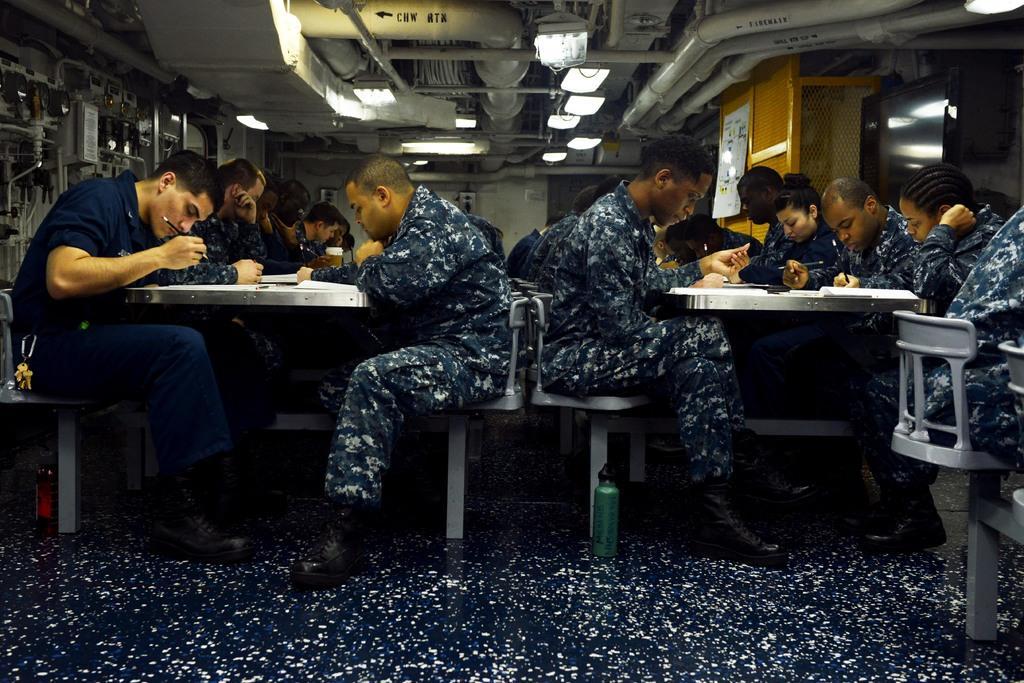Describe this image in one or two sentences. In this picture there are group of people sitting on the chair. There is a pencil, book, cup on the table. There are some lights, pipes. There is a poster. 